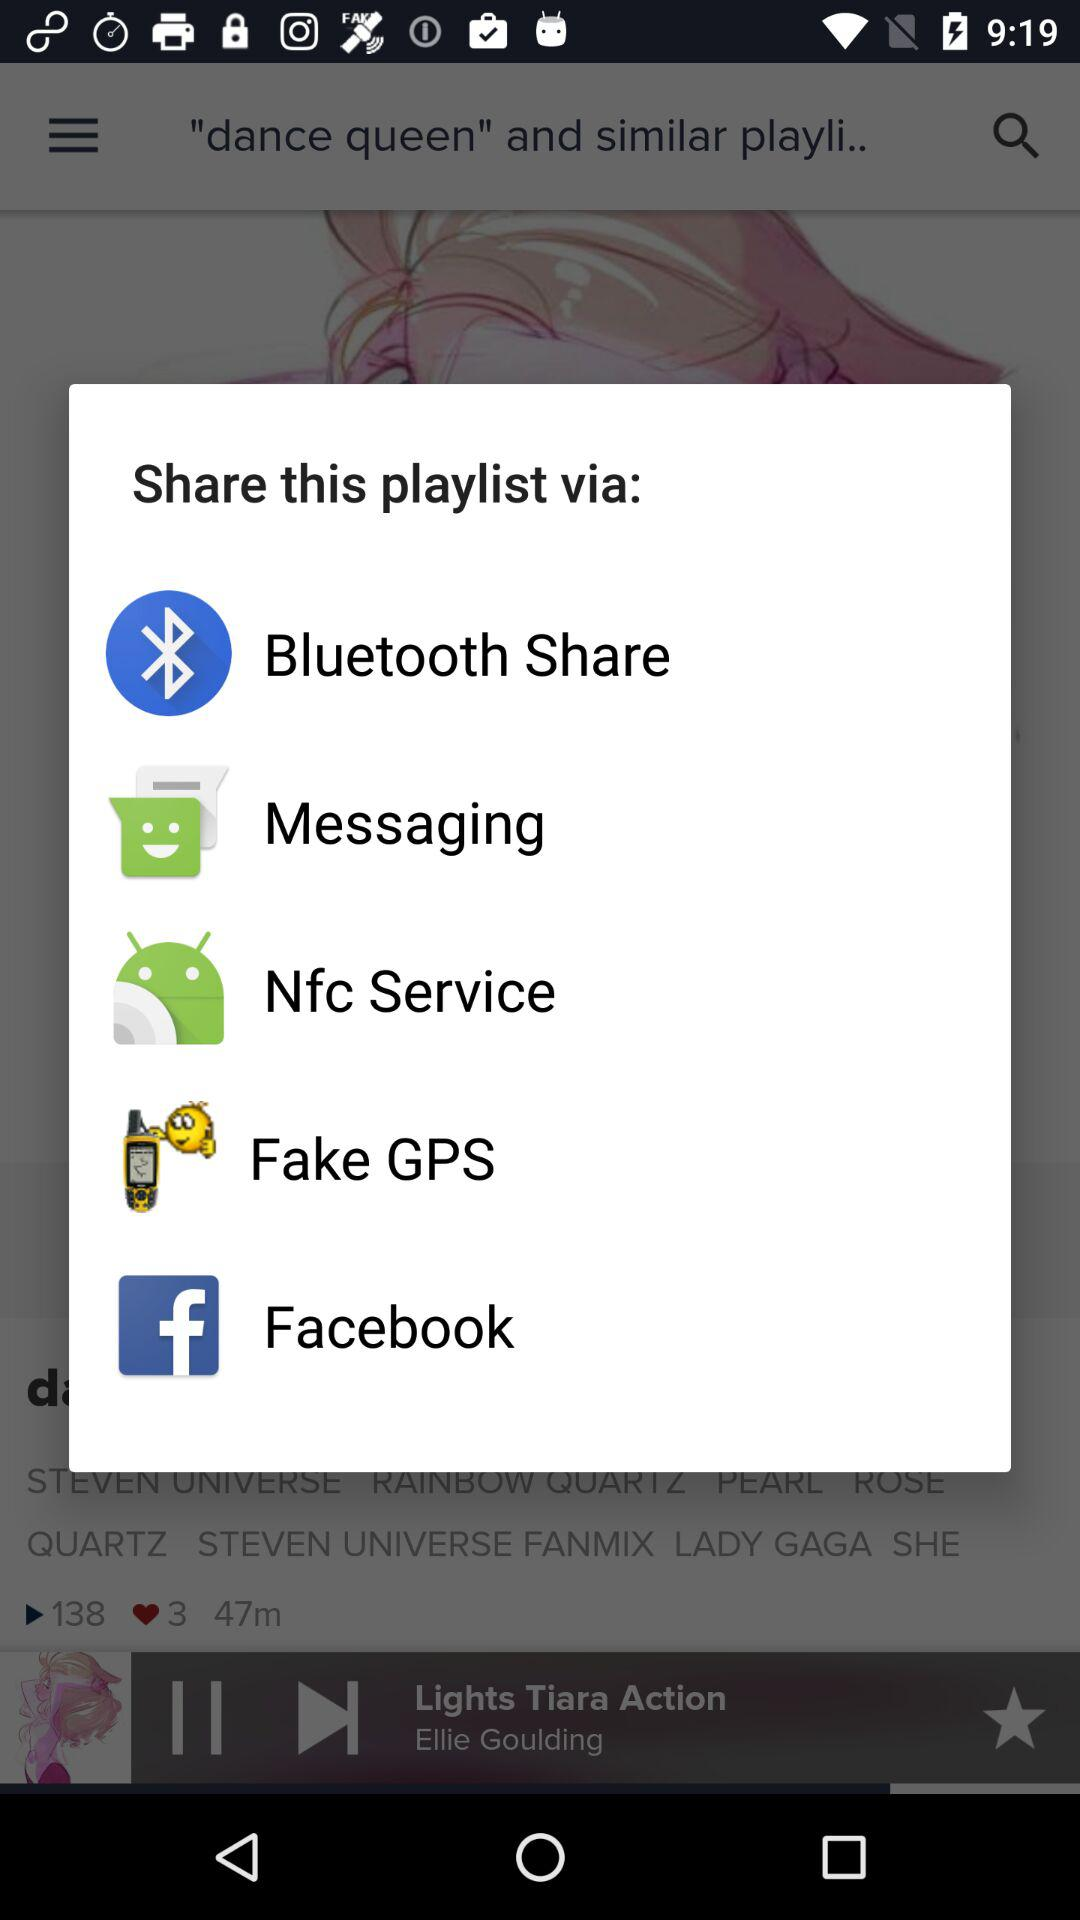What is the current playing song name? The current playing song name is "Lights Tiara Action". 